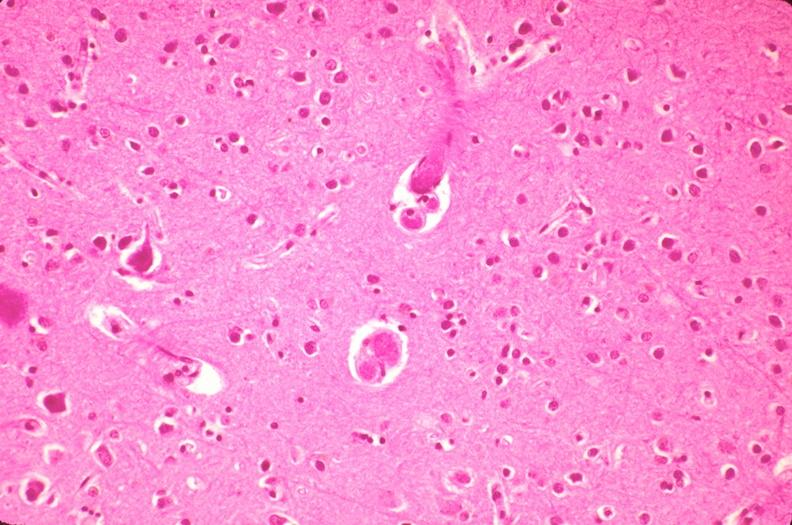what is present?
Answer the question using a single word or phrase. Nervous 